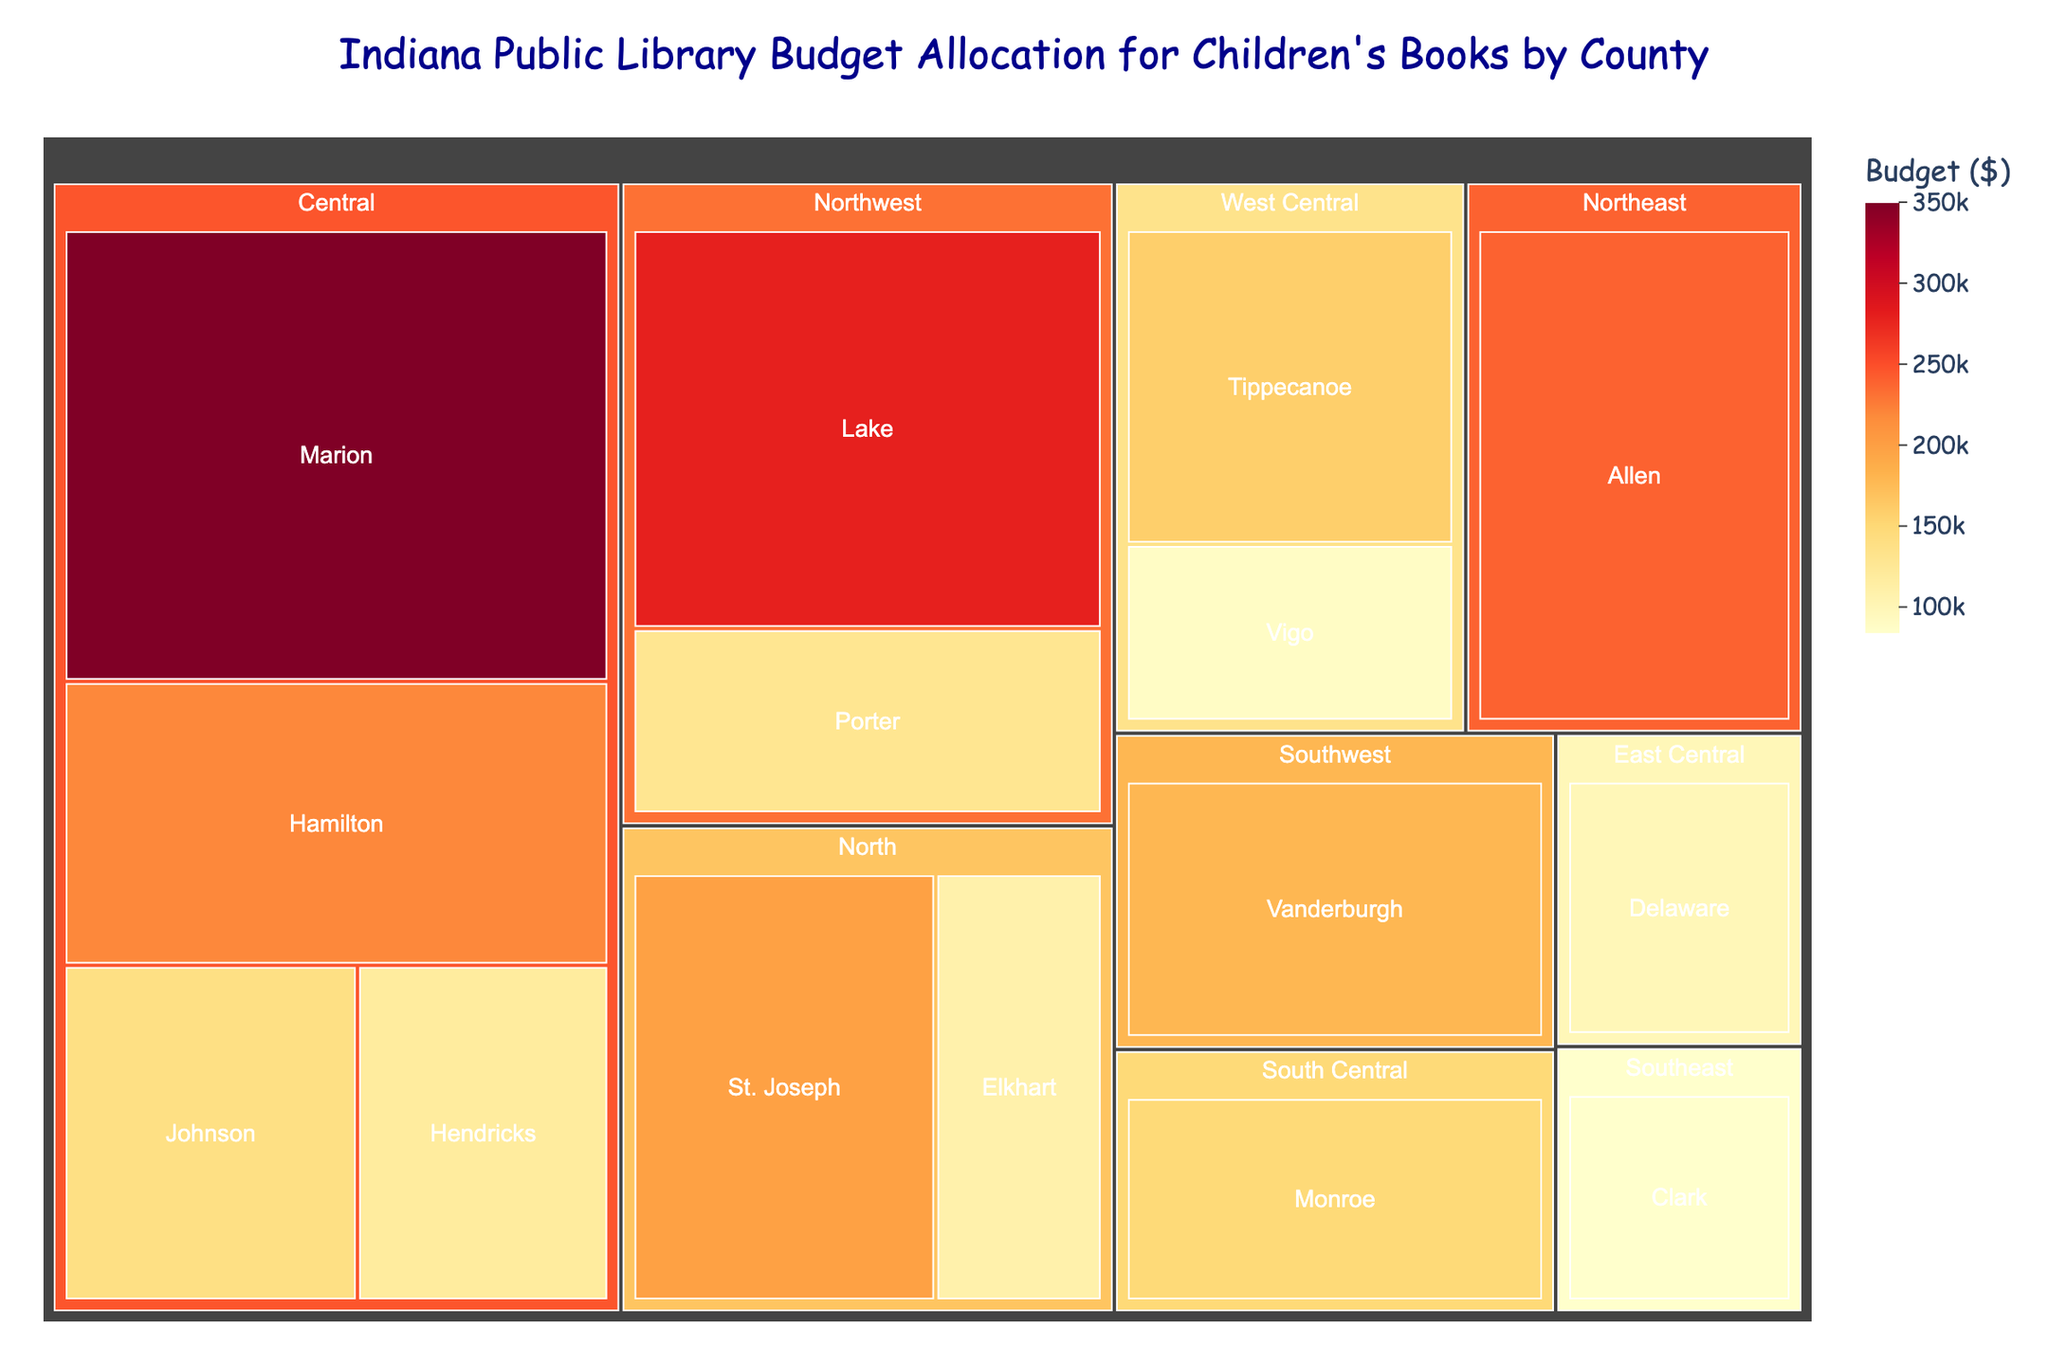What is the title of the figure? The title is typically displayed at the top of the figure. In this case, the title given is "Indiana Public Library Budget Allocation for Children's Books by County".
Answer: Indiana Public Library Budget Allocation for Children's Books by County What region has the highest budget allocation? To identify the region with the highest budget allocation, sum the budgets of all counties within each region and compare them. The Central region has Marion ($350,000), Hamilton ($220,000), Johnson ($140,000), and Hendricks ($120,000). Adding these gives a total of $830,000, which is the highest compared to other regions.
Answer: Central Which county in the Central region has the smallest budget allocation? The counties in the Central region are Marion, Hamilton, Johnson, and Hendricks. By comparing their budgets: Marion ($350,000), Hamilton ($220,000), Johnson ($140,000), and Hendricks ($120,000), the smallest budget is in Hendricks.
Answer: Hendricks How much more budget does Marion County have compared to Porter County? Marion County has a budget of $350,000 and Porter County has a budget of $130,000. The difference is $350,000 - $130,000 = $220,000.
Answer: $220,000 What is the average budget allocation per county in the Northeast region? The Northeast region has one county listed, which is Allen County with a budget of $240,000. Since there's only one county, the average budget is $240,000.
Answer: $240,000 Which region has the least budget allocation and what is the total? To determine the region with the least budget allocation, sum up the budgets for all regions and compare. The Southeast region has only Clark County with a budget of $85,000. This is the smallest total compared to other regions.
Answer: Southeast, $85,000 How many counties have a budget allocation of $200,000 or more? By identifying counties with budgets equal to or above $200,000: Marion ($350,000), Lake ($280,000), Allen ($240,000), Hamilton ($220,000), and St. Joseph ($200,000). There are 5 counties that meet this criterion.
Answer: 5 What is the combined budget for the counties in the West Central region? The West Central region includes Tippecanoe ($160,000) and Vigo ($90,000). Their combined budget is $160,000 + $90,000 = $250,000.
Answer: $250,000 Which county has the second-highest budget allocation, and what is the amount? By examining and comparing all county budgets: the highest is Marion ($350,000), and the second-highest is Lake with $280,000.
Answer: Lake, $280,000 